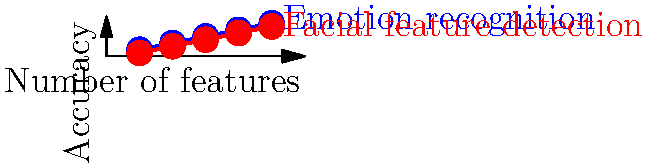As a mathematics researcher considering the IQ debate, analyze the graph showing the relationship between the number of facial features used and the accuracy of emotion recognition and facial feature detection algorithms. If we were to add a sixth feature, what would be the expected accuracy for emotion recognition, assuming the trend continues linearly? To solve this problem, we need to follow these steps:

1. Observe the trend for emotion recognition (blue line):
   The data points are (1, 0.2), (2, 0.4), (3, 0.6), (4, 0.8), (5, 1.0)

2. Calculate the slope of the line:
   $m = \frac{y_2 - y_1}{x_2 - x_1} = \frac{1.0 - 0.2}{5 - 1} = \frac{0.8}{4} = 0.2$

3. Determine the linear equation:
   $y = mx + b$
   $y = 0.2x + 0$

4. To find the expected accuracy for 6 features, substitute x = 6:
   $y = 0.2(6) + 0 = 1.2$

5. Interpret the result:
   The expected accuracy for emotion recognition with 6 features would be 1.2 or 120%.

6. Consider the implications:
   As a researcher considering the IQ debate, we should note that this linear extrapolation might not be realistic. Accuracy cannot exceed 100%, suggesting that the relationship may not remain linear beyond the given data points. This highlights the importance of considering practical limitations when interpreting statistical trends, especially in complex domains like facial recognition and emotion detection.
Answer: 1.2 (120% accuracy, not realistic) 